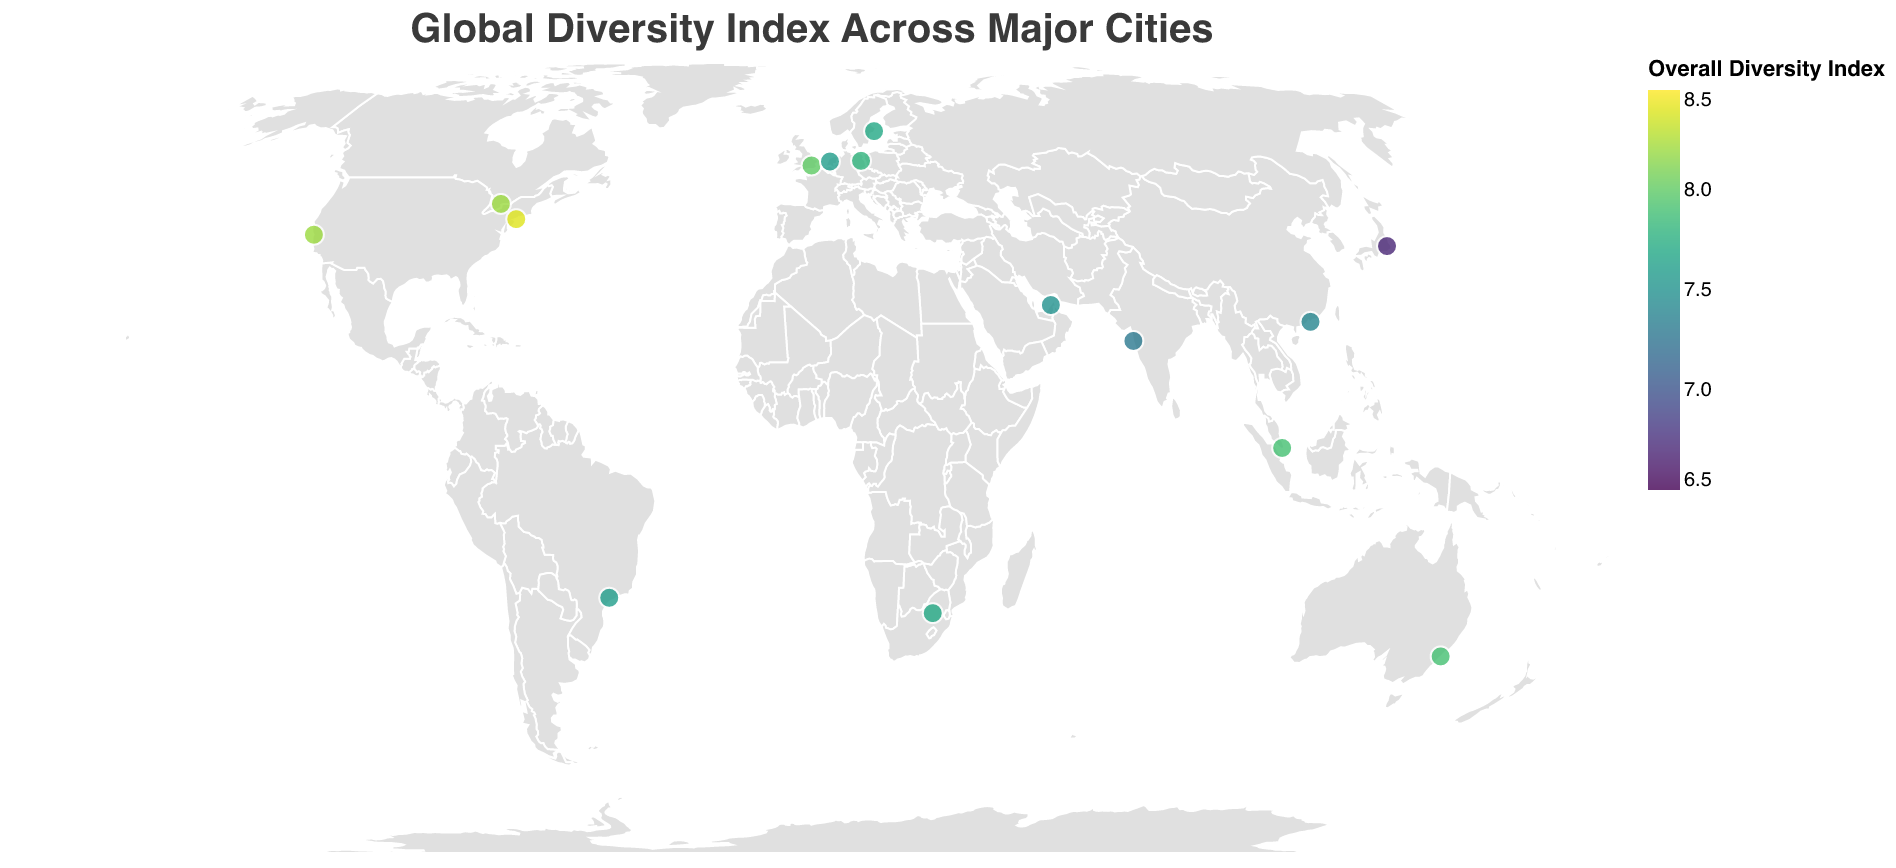what is the city with the highest Gender Diversity Score? Referring to the tooltip data, San Francisco has the highest Gender Diversity Score of 8.4.
Answer: San Francisco Which city has the lowest Overall Diversity Index? Based on the visual data, Tokyo has the lowest Overall Diversity Index of 6.7.
Answer: Tokyo What is the average Ethnic Diversity Score of cities in the USA? The cities listed in the USA are New York with a score of 9.1 and San Francisco with a score of 8.8. Average = (9.1 + 8.8) / 2 = 8.95.
Answer: 8.95 Which city in Europe has the highest Overall Diversity Index? From the cities listed in Europe, London has the highest overall Diversity Index of 8.0.
Answer: London Which city in Asia has the highest Ethnic Diversity Score, and what is that score? Singapore has the highest Ethnic Diversity Score in Asia with a score of 9.3.
Answer: Singapore, 9.3 What is the difference in Overall Diversity Index between the cities with the highest and lowest scores? The highest score is 8.4 for New York and the lowest is 6.7 for Tokyo. Difference = 8.4 - 6.7 = 1.7.
Answer: 1.7 How does the Overall Diversity Index of Dubai compare to Tokyo? Dubai has an Overall Diversity Index of 7.5, whereas Tokyo has 6.7, making Dubai's score higher.
Answer: Dubai's score is higher What is the average Age Diversity Score across all cities? Sum all Age Diversity Scores: (7.8 + 7.5 + 6.9 + 7.6 + 7.4 + 7.1 + 6.7 + 7.2 + 7.9 + 7.3 + 7.6 + 6.8 + 7.0 + 7.5 + 7.2) = 108.5. There are 15 cities. Average = 108.5 / 15 ≈ 7.23.
Answer: 7.23 Which city has the largest difference between its Gender Diversity Score and Ethnic Diversity Score? Comparing the differences, Singapore has the largest difference (9.3 - 7.5 = 1.8).
Answer: Singapore Can you identify the city with the highest Overall Diversity Index in North America? The cities listed in North America are New York, Toronto, and San Francisco. New York has the highest Overall Diversity Index of 8.4.
Answer: New York 